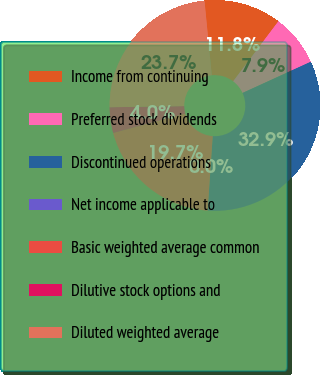<chart> <loc_0><loc_0><loc_500><loc_500><pie_chart><fcel>Income from continuing<fcel>Preferred stock dividends<fcel>Discontinued operations<fcel>Net income applicable to<fcel>Basic weighted average common<fcel>Dilutive stock options and<fcel>Diluted weighted average<nl><fcel>11.84%<fcel>7.89%<fcel>32.9%<fcel>0.0%<fcel>19.73%<fcel>3.95%<fcel>23.68%<nl></chart> 